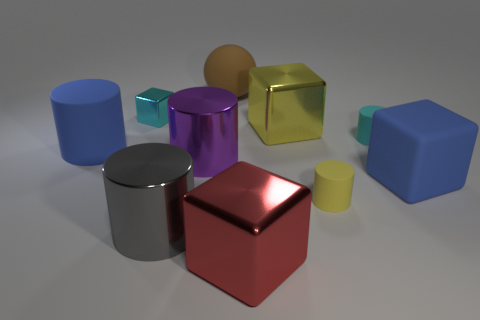Subtract all yellow cylinders. How many cylinders are left? 4 Subtract 2 cubes. How many cubes are left? 2 Subtract all tiny cyan blocks. How many blocks are left? 3 Subtract all balls. How many objects are left? 9 Subtract all small blue cubes. Subtract all large gray things. How many objects are left? 9 Add 1 brown rubber spheres. How many brown rubber spheres are left? 2 Add 1 large blocks. How many large blocks exist? 4 Subtract 1 cyan cubes. How many objects are left? 9 Subtract all red cylinders. Subtract all cyan spheres. How many cylinders are left? 5 